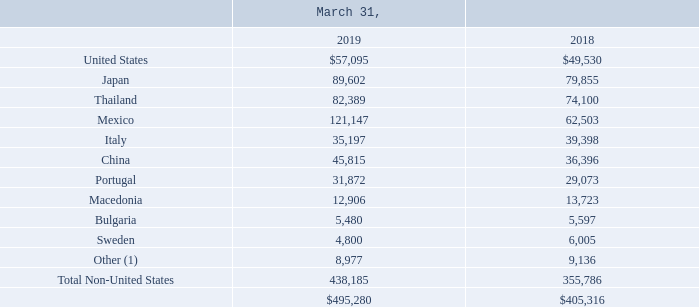Notes to Consolidated Financial Statements (Continued)
The following geographic information includes Property, plant and equipment, net, based on physical location (amounts in thousands):
(1) No country included in this caption exceeded 1% of consolidated Property, plant and equipment net for fiscal years 2019 and 2018.
Which years does the table provide information for Property, plant and equipment, net, based on physical location? 2019, 2018. What was the net amount of property, plant and equipment in Japan in 2019?
Answer scale should be: thousand. 89,602. What was the net amount of property, plant and equipment in Thailand in 2018?
Answer scale should be: thousand. 74,100. How many years did Total net property, plant and equipment from Non-United States regions exceed $400,000 thousand? 2019
Answer: 1. What was the change in the net property, plant and equipment in China between 2018 and 2019?
Answer scale should be: thousand. 45,815-36,396
Answer: 9419. What was the percentage change in the total net property, plant and equipment between 2018 and 2019?
Answer scale should be: percent. (495,280-405,316)/405,316
Answer: 22.2. 